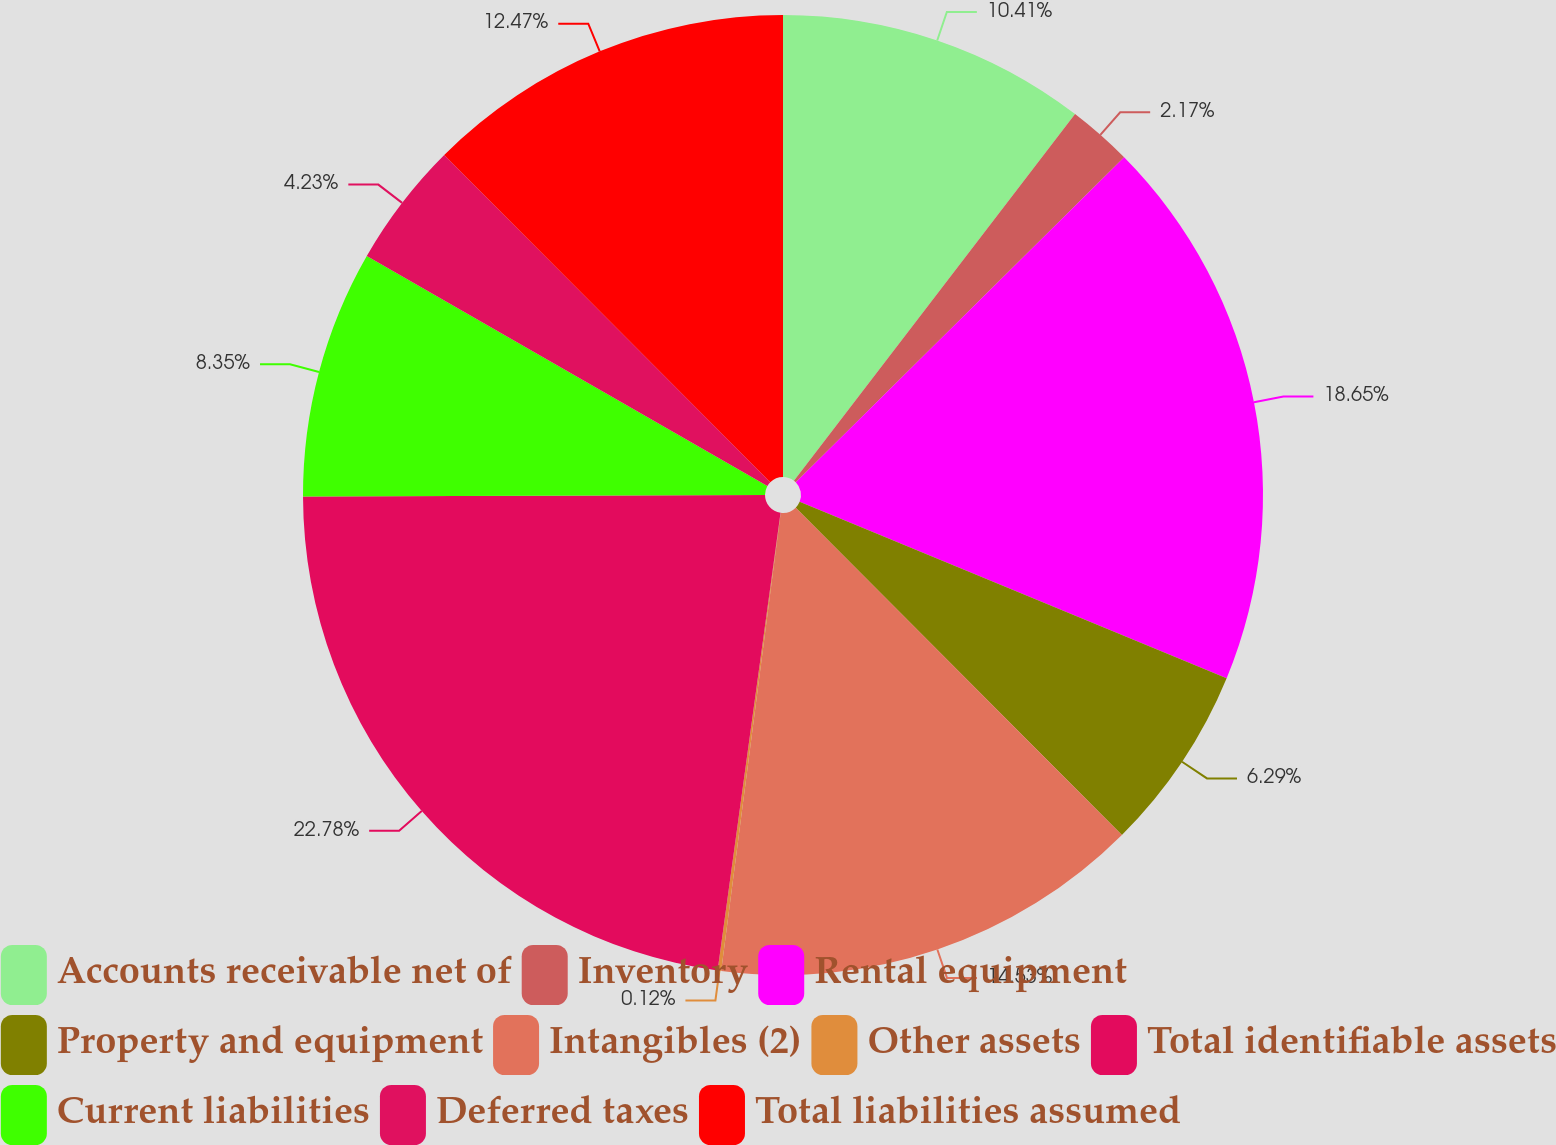Convert chart to OTSL. <chart><loc_0><loc_0><loc_500><loc_500><pie_chart><fcel>Accounts receivable net of<fcel>Inventory<fcel>Rental equipment<fcel>Property and equipment<fcel>Intangibles (2)<fcel>Other assets<fcel>Total identifiable assets<fcel>Current liabilities<fcel>Deferred taxes<fcel>Total liabilities assumed<nl><fcel>10.41%<fcel>2.17%<fcel>18.65%<fcel>6.29%<fcel>14.53%<fcel>0.12%<fcel>22.77%<fcel>8.35%<fcel>4.23%<fcel>12.47%<nl></chart> 